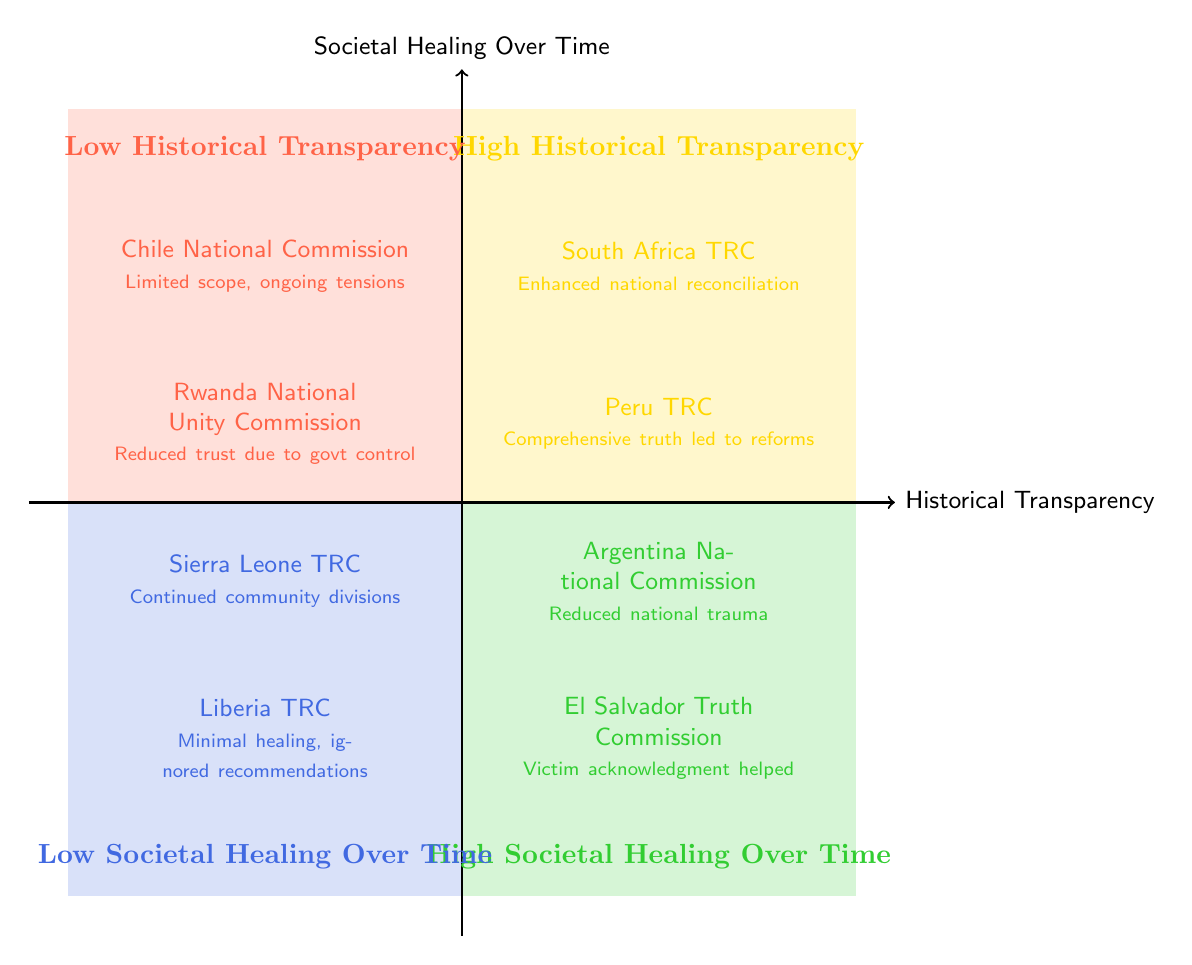What are the two impacts listed under High Historical Transparency? The two impacts listed in this quadrant are "South Africa TRC" and "Peru TRC." These are specifically located in the upper right quadrant of the diagram.
Answer: South Africa TRC, Peru TRC What effect is associated with the Argentina National Commission? The effect associated with Argentina's commission, which is in the High Societal Healing Over Time quadrant, indicates a significant reduction in national trauma through extensive documentation. This is based on the text present in that quadrant.
Answer: Significant reduction in national trauma How many total impacts are listed in the Low Societal Healing Over Time quadrant? There are two impacts listed in the Low Societal Healing Over Time quadrant, which can be counted directly from the information displayed in that area of the diagram.
Answer: 2 Which truth commission is associated with "Limited scope led to ongoing societal tensions"? This specific effect corresponds to the "Chile National Commission on Truth and Reconciliation." It can be found in the Low Historical Transparency quadrant of the diagram.
Answer: Chile National Commission on Truth and Reconciliation What relationship can be inferred between High Historical Transparency and High Societal Healing Over Time? The relationship suggests that high historical transparency, as seen with examples like South Africa and Peru, correlates positively with societal healing over time, demonstrated by cases like Argentina and El Salvador. Thus, one can infer that higher transparency may lead to better healing outcomes.
Answer: Positive correlation Which truth commission is noted for helping societal healing despite limited prosecutions? The truth commission noted for this effect is the "El Salvador Truth Commission," found in the High Societal Healing Over Time quadrant. This can be identified clearly from the information in that section of the diagram.
Answer: El Salvador Truth Commission What is a common issue seen in the Low Historical Transparency quadrant? A common issue is that the truth commissions in this quadrant often lead to ongoing societal tensions or reduced trust due to perceived limitations or governmental control. This can be deduced from the effects associated with the commissions listed in that quadrant.
Answer: Ongoing societal tensions Which two impacts share the theme of community divisions? The impacts that share this theme are "Sierra Leone Truth and Reconciliation Commission" and "Liberia Truth and Reconciliation Commission," both found in the Low Societal Healing Over Time quadrant. This can be traced based on the effects outlined for those commissions.
Answer: Sierra Leone TRC, Liberia TRC What does the Peru TRC specifically contribute to according to the diagram? The Peru TRC is said to lead to "educational reforms," indicating its contribution to societal improvements through truth restoration, which is directly stated in the quadrant where it is located.
Answer: Educational reforms 